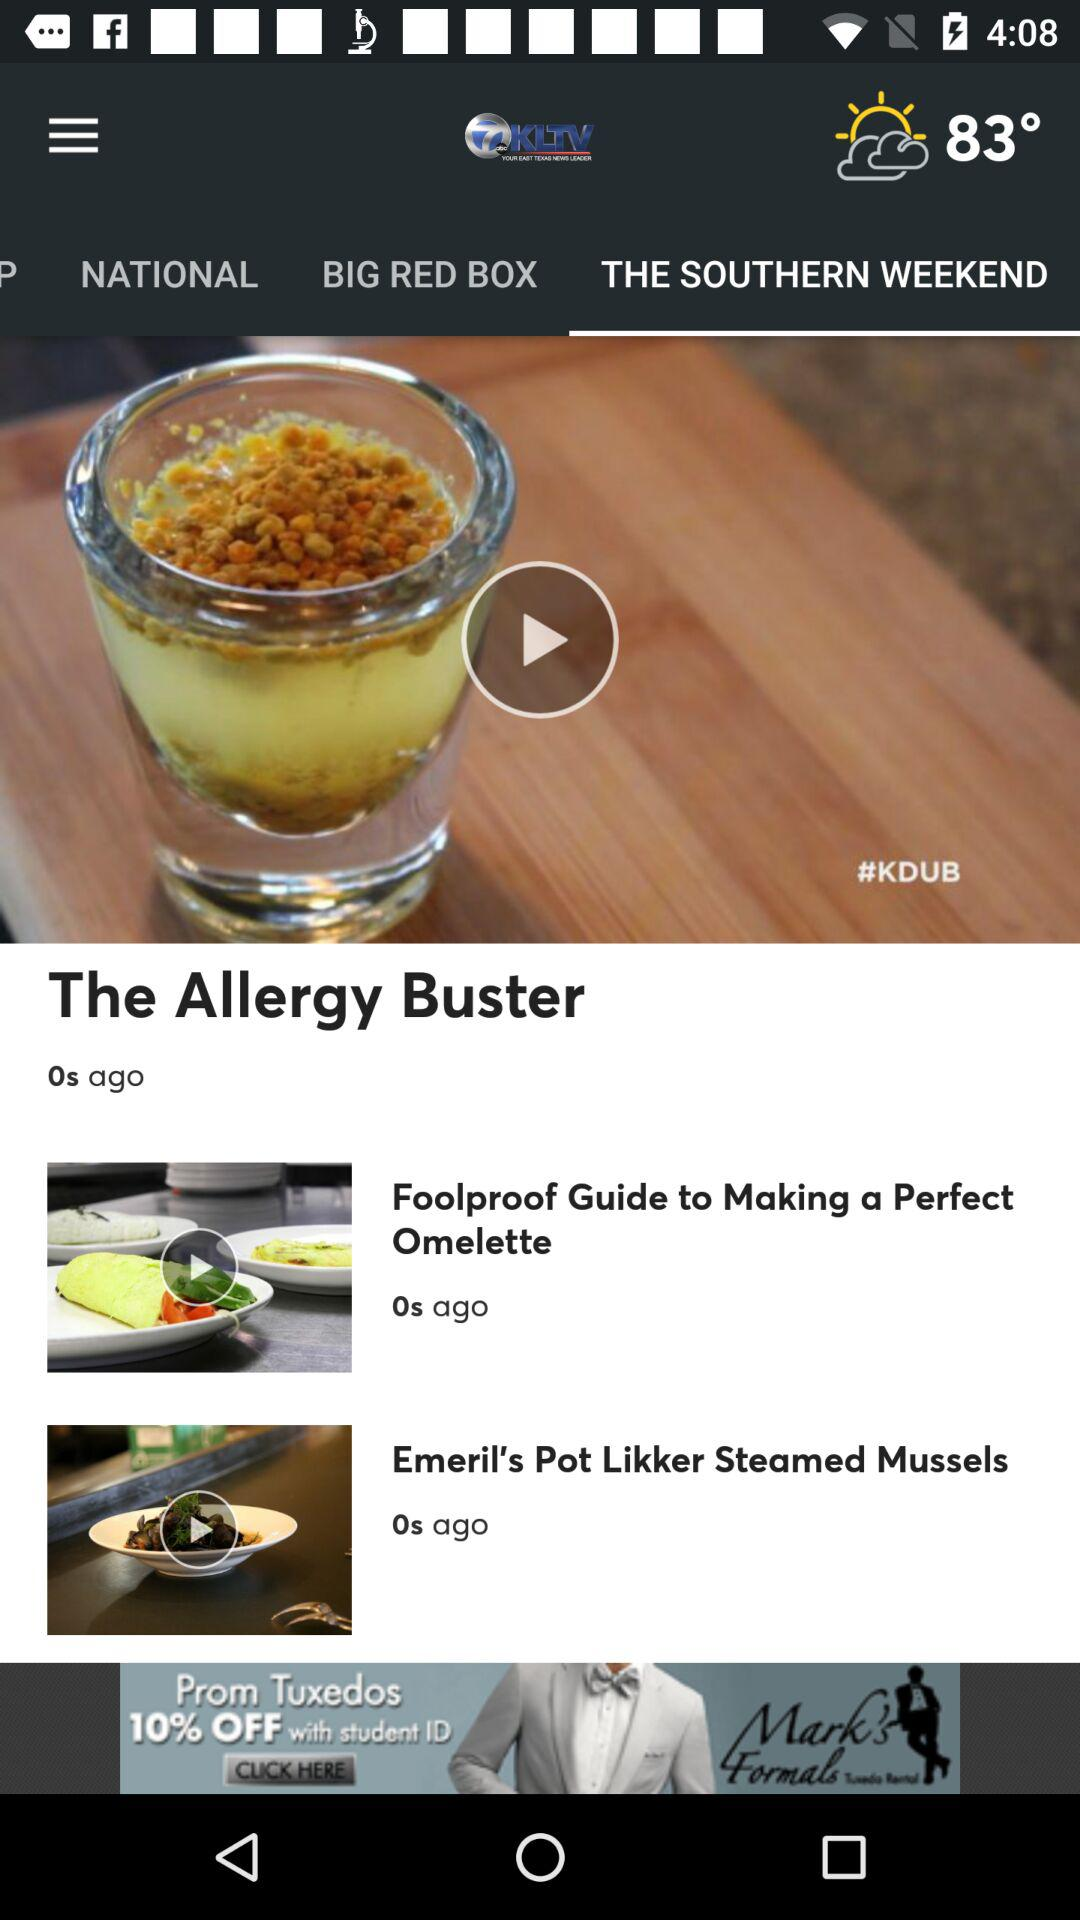When was the "Foolproof Guide to Making a Perfect Omelette" video uploaded? The "Foolproof Guide to Making a Perfect Omelette" video was uploaded 0 seconds ago. 